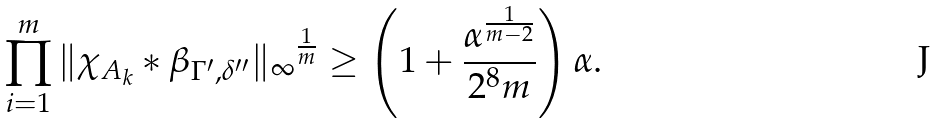<formula> <loc_0><loc_0><loc_500><loc_500>\prod _ { i = 1 } ^ { m } { \| \chi _ { A _ { k } } \ast \beta _ { \Gamma ^ { \prime } , \delta ^ { \prime \prime } } \| _ { \infty } } ^ { \frac { 1 } { m } } \geq \left ( 1 + \frac { \alpha ^ { \frac { 1 } { m - 2 } } } { 2 ^ { 8 } m } \right ) \alpha .</formula> 